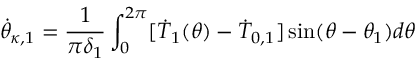<formula> <loc_0><loc_0><loc_500><loc_500>\dot { \theta } _ { \kappa , 1 } = \frac { 1 } { \pi \delta _ { 1 } } \int _ { 0 } ^ { 2 \pi } [ \dot { T } _ { 1 } ( \theta ) - \dot { T } _ { 0 , 1 } ] \sin ( \theta - \theta _ { 1 } ) d \theta</formula> 